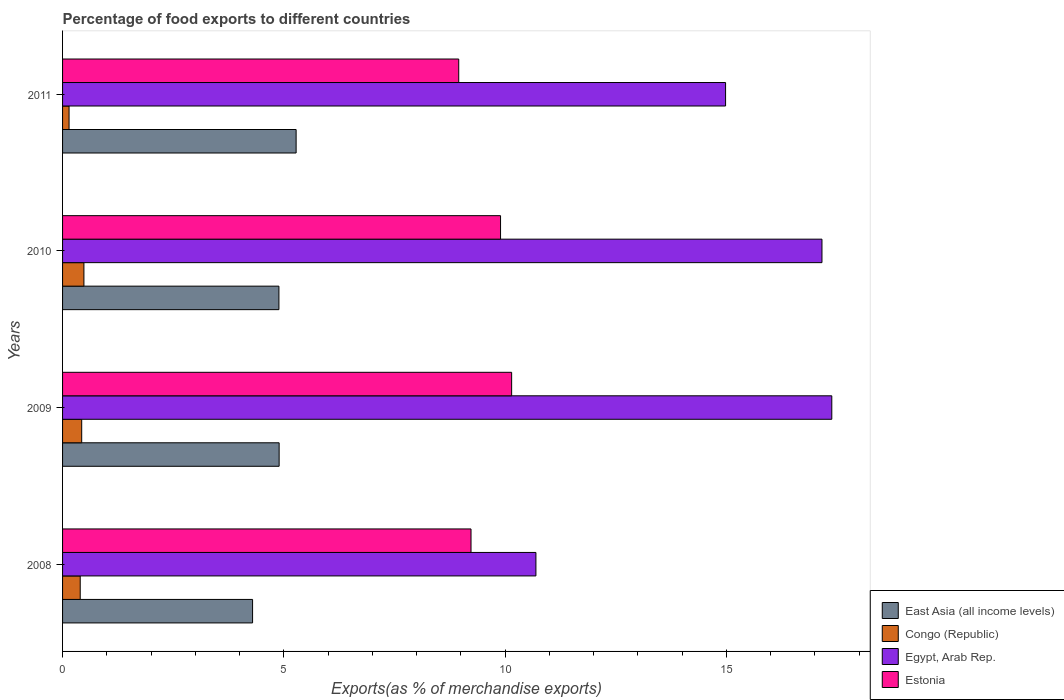How many different coloured bars are there?
Give a very brief answer. 4. How many groups of bars are there?
Your response must be concise. 4. How many bars are there on the 1st tick from the bottom?
Offer a terse response. 4. What is the label of the 3rd group of bars from the top?
Ensure brevity in your answer.  2009. What is the percentage of exports to different countries in Estonia in 2011?
Provide a succinct answer. 8.95. Across all years, what is the maximum percentage of exports to different countries in Congo (Republic)?
Provide a succinct answer. 0.48. Across all years, what is the minimum percentage of exports to different countries in East Asia (all income levels)?
Offer a terse response. 4.29. What is the total percentage of exports to different countries in Estonia in the graph?
Keep it short and to the point. 38.23. What is the difference between the percentage of exports to different countries in East Asia (all income levels) in 2010 and that in 2011?
Offer a terse response. -0.39. What is the difference between the percentage of exports to different countries in Egypt, Arab Rep. in 2009 and the percentage of exports to different countries in East Asia (all income levels) in 2008?
Give a very brief answer. 13.09. What is the average percentage of exports to different countries in Estonia per year?
Your answer should be very brief. 9.56. In the year 2009, what is the difference between the percentage of exports to different countries in Egypt, Arab Rep. and percentage of exports to different countries in Estonia?
Provide a short and direct response. 7.24. What is the ratio of the percentage of exports to different countries in Egypt, Arab Rep. in 2009 to that in 2010?
Give a very brief answer. 1.01. Is the difference between the percentage of exports to different countries in Egypt, Arab Rep. in 2009 and 2010 greater than the difference between the percentage of exports to different countries in Estonia in 2009 and 2010?
Provide a short and direct response. No. What is the difference between the highest and the second highest percentage of exports to different countries in Egypt, Arab Rep.?
Provide a short and direct response. 0.22. What is the difference between the highest and the lowest percentage of exports to different countries in East Asia (all income levels)?
Ensure brevity in your answer.  0.98. Is the sum of the percentage of exports to different countries in Egypt, Arab Rep. in 2009 and 2010 greater than the maximum percentage of exports to different countries in East Asia (all income levels) across all years?
Offer a very short reply. Yes. What does the 1st bar from the top in 2009 represents?
Offer a very short reply. Estonia. What does the 1st bar from the bottom in 2009 represents?
Provide a short and direct response. East Asia (all income levels). How many years are there in the graph?
Your response must be concise. 4. What is the difference between two consecutive major ticks on the X-axis?
Provide a short and direct response. 5. Does the graph contain grids?
Give a very brief answer. No. Where does the legend appear in the graph?
Your response must be concise. Bottom right. How many legend labels are there?
Ensure brevity in your answer.  4. What is the title of the graph?
Offer a terse response. Percentage of food exports to different countries. Does "Bulgaria" appear as one of the legend labels in the graph?
Provide a short and direct response. No. What is the label or title of the X-axis?
Offer a terse response. Exports(as % of merchandise exports). What is the label or title of the Y-axis?
Offer a very short reply. Years. What is the Exports(as % of merchandise exports) of East Asia (all income levels) in 2008?
Offer a very short reply. 4.29. What is the Exports(as % of merchandise exports) in Congo (Republic) in 2008?
Ensure brevity in your answer.  0.4. What is the Exports(as % of merchandise exports) in Egypt, Arab Rep. in 2008?
Give a very brief answer. 10.7. What is the Exports(as % of merchandise exports) of Estonia in 2008?
Provide a short and direct response. 9.23. What is the Exports(as % of merchandise exports) in East Asia (all income levels) in 2009?
Offer a terse response. 4.89. What is the Exports(as % of merchandise exports) of Congo (Republic) in 2009?
Make the answer very short. 0.43. What is the Exports(as % of merchandise exports) in Egypt, Arab Rep. in 2009?
Your response must be concise. 17.38. What is the Exports(as % of merchandise exports) of Estonia in 2009?
Ensure brevity in your answer.  10.15. What is the Exports(as % of merchandise exports) of East Asia (all income levels) in 2010?
Give a very brief answer. 4.89. What is the Exports(as % of merchandise exports) of Congo (Republic) in 2010?
Your response must be concise. 0.48. What is the Exports(as % of merchandise exports) of Egypt, Arab Rep. in 2010?
Keep it short and to the point. 17.16. What is the Exports(as % of merchandise exports) in Estonia in 2010?
Your answer should be compact. 9.9. What is the Exports(as % of merchandise exports) in East Asia (all income levels) in 2011?
Keep it short and to the point. 5.28. What is the Exports(as % of merchandise exports) of Congo (Republic) in 2011?
Provide a succinct answer. 0.15. What is the Exports(as % of merchandise exports) in Egypt, Arab Rep. in 2011?
Ensure brevity in your answer.  14.98. What is the Exports(as % of merchandise exports) of Estonia in 2011?
Your response must be concise. 8.95. Across all years, what is the maximum Exports(as % of merchandise exports) in East Asia (all income levels)?
Offer a terse response. 5.28. Across all years, what is the maximum Exports(as % of merchandise exports) of Congo (Republic)?
Offer a terse response. 0.48. Across all years, what is the maximum Exports(as % of merchandise exports) of Egypt, Arab Rep.?
Ensure brevity in your answer.  17.38. Across all years, what is the maximum Exports(as % of merchandise exports) in Estonia?
Give a very brief answer. 10.15. Across all years, what is the minimum Exports(as % of merchandise exports) in East Asia (all income levels)?
Offer a terse response. 4.29. Across all years, what is the minimum Exports(as % of merchandise exports) of Congo (Republic)?
Your answer should be very brief. 0.15. Across all years, what is the minimum Exports(as % of merchandise exports) of Egypt, Arab Rep.?
Provide a succinct answer. 10.7. Across all years, what is the minimum Exports(as % of merchandise exports) in Estonia?
Offer a terse response. 8.95. What is the total Exports(as % of merchandise exports) of East Asia (all income levels) in the graph?
Your answer should be very brief. 19.36. What is the total Exports(as % of merchandise exports) in Congo (Republic) in the graph?
Give a very brief answer. 1.46. What is the total Exports(as % of merchandise exports) in Egypt, Arab Rep. in the graph?
Offer a terse response. 60.23. What is the total Exports(as % of merchandise exports) of Estonia in the graph?
Your response must be concise. 38.23. What is the difference between the Exports(as % of merchandise exports) of East Asia (all income levels) in 2008 and that in 2009?
Your answer should be very brief. -0.6. What is the difference between the Exports(as % of merchandise exports) in Congo (Republic) in 2008 and that in 2009?
Provide a short and direct response. -0.03. What is the difference between the Exports(as % of merchandise exports) in Egypt, Arab Rep. in 2008 and that in 2009?
Keep it short and to the point. -6.69. What is the difference between the Exports(as % of merchandise exports) of Estonia in 2008 and that in 2009?
Your answer should be compact. -0.92. What is the difference between the Exports(as % of merchandise exports) in East Asia (all income levels) in 2008 and that in 2010?
Offer a terse response. -0.6. What is the difference between the Exports(as % of merchandise exports) in Congo (Republic) in 2008 and that in 2010?
Provide a short and direct response. -0.08. What is the difference between the Exports(as % of merchandise exports) in Egypt, Arab Rep. in 2008 and that in 2010?
Ensure brevity in your answer.  -6.46. What is the difference between the Exports(as % of merchandise exports) in Estonia in 2008 and that in 2010?
Provide a succinct answer. -0.67. What is the difference between the Exports(as % of merchandise exports) in East Asia (all income levels) in 2008 and that in 2011?
Offer a terse response. -0.98. What is the difference between the Exports(as % of merchandise exports) of Congo (Republic) in 2008 and that in 2011?
Make the answer very short. 0.25. What is the difference between the Exports(as % of merchandise exports) in Egypt, Arab Rep. in 2008 and that in 2011?
Give a very brief answer. -4.29. What is the difference between the Exports(as % of merchandise exports) of Estonia in 2008 and that in 2011?
Keep it short and to the point. 0.28. What is the difference between the Exports(as % of merchandise exports) of East Asia (all income levels) in 2009 and that in 2010?
Your response must be concise. 0. What is the difference between the Exports(as % of merchandise exports) of Congo (Republic) in 2009 and that in 2010?
Your response must be concise. -0.05. What is the difference between the Exports(as % of merchandise exports) of Egypt, Arab Rep. in 2009 and that in 2010?
Make the answer very short. 0.22. What is the difference between the Exports(as % of merchandise exports) of Estonia in 2009 and that in 2010?
Your answer should be very brief. 0.25. What is the difference between the Exports(as % of merchandise exports) of East Asia (all income levels) in 2009 and that in 2011?
Provide a short and direct response. -0.38. What is the difference between the Exports(as % of merchandise exports) of Congo (Republic) in 2009 and that in 2011?
Your answer should be very brief. 0.29. What is the difference between the Exports(as % of merchandise exports) of Egypt, Arab Rep. in 2009 and that in 2011?
Ensure brevity in your answer.  2.4. What is the difference between the Exports(as % of merchandise exports) of Estonia in 2009 and that in 2011?
Your answer should be compact. 1.2. What is the difference between the Exports(as % of merchandise exports) in East Asia (all income levels) in 2010 and that in 2011?
Your answer should be compact. -0.39. What is the difference between the Exports(as % of merchandise exports) in Congo (Republic) in 2010 and that in 2011?
Give a very brief answer. 0.34. What is the difference between the Exports(as % of merchandise exports) in Egypt, Arab Rep. in 2010 and that in 2011?
Your response must be concise. 2.18. What is the difference between the Exports(as % of merchandise exports) of Estonia in 2010 and that in 2011?
Your answer should be very brief. 0.95. What is the difference between the Exports(as % of merchandise exports) of East Asia (all income levels) in 2008 and the Exports(as % of merchandise exports) of Congo (Republic) in 2009?
Offer a terse response. 3.86. What is the difference between the Exports(as % of merchandise exports) in East Asia (all income levels) in 2008 and the Exports(as % of merchandise exports) in Egypt, Arab Rep. in 2009?
Keep it short and to the point. -13.09. What is the difference between the Exports(as % of merchandise exports) in East Asia (all income levels) in 2008 and the Exports(as % of merchandise exports) in Estonia in 2009?
Ensure brevity in your answer.  -5.86. What is the difference between the Exports(as % of merchandise exports) in Congo (Republic) in 2008 and the Exports(as % of merchandise exports) in Egypt, Arab Rep. in 2009?
Provide a short and direct response. -16.99. What is the difference between the Exports(as % of merchandise exports) of Congo (Republic) in 2008 and the Exports(as % of merchandise exports) of Estonia in 2009?
Keep it short and to the point. -9.75. What is the difference between the Exports(as % of merchandise exports) in Egypt, Arab Rep. in 2008 and the Exports(as % of merchandise exports) in Estonia in 2009?
Your answer should be very brief. 0.55. What is the difference between the Exports(as % of merchandise exports) in East Asia (all income levels) in 2008 and the Exports(as % of merchandise exports) in Congo (Republic) in 2010?
Give a very brief answer. 3.81. What is the difference between the Exports(as % of merchandise exports) of East Asia (all income levels) in 2008 and the Exports(as % of merchandise exports) of Egypt, Arab Rep. in 2010?
Keep it short and to the point. -12.87. What is the difference between the Exports(as % of merchandise exports) of East Asia (all income levels) in 2008 and the Exports(as % of merchandise exports) of Estonia in 2010?
Your answer should be very brief. -5.6. What is the difference between the Exports(as % of merchandise exports) in Congo (Republic) in 2008 and the Exports(as % of merchandise exports) in Egypt, Arab Rep. in 2010?
Offer a very short reply. -16.76. What is the difference between the Exports(as % of merchandise exports) of Congo (Republic) in 2008 and the Exports(as % of merchandise exports) of Estonia in 2010?
Your response must be concise. -9.5. What is the difference between the Exports(as % of merchandise exports) in Egypt, Arab Rep. in 2008 and the Exports(as % of merchandise exports) in Estonia in 2010?
Your answer should be compact. 0.8. What is the difference between the Exports(as % of merchandise exports) of East Asia (all income levels) in 2008 and the Exports(as % of merchandise exports) of Congo (Republic) in 2011?
Your response must be concise. 4.15. What is the difference between the Exports(as % of merchandise exports) of East Asia (all income levels) in 2008 and the Exports(as % of merchandise exports) of Egypt, Arab Rep. in 2011?
Make the answer very short. -10.69. What is the difference between the Exports(as % of merchandise exports) of East Asia (all income levels) in 2008 and the Exports(as % of merchandise exports) of Estonia in 2011?
Ensure brevity in your answer.  -4.66. What is the difference between the Exports(as % of merchandise exports) of Congo (Republic) in 2008 and the Exports(as % of merchandise exports) of Egypt, Arab Rep. in 2011?
Your response must be concise. -14.59. What is the difference between the Exports(as % of merchandise exports) in Congo (Republic) in 2008 and the Exports(as % of merchandise exports) in Estonia in 2011?
Your answer should be very brief. -8.55. What is the difference between the Exports(as % of merchandise exports) in Egypt, Arab Rep. in 2008 and the Exports(as % of merchandise exports) in Estonia in 2011?
Your answer should be compact. 1.74. What is the difference between the Exports(as % of merchandise exports) of East Asia (all income levels) in 2009 and the Exports(as % of merchandise exports) of Congo (Republic) in 2010?
Provide a succinct answer. 4.41. What is the difference between the Exports(as % of merchandise exports) in East Asia (all income levels) in 2009 and the Exports(as % of merchandise exports) in Egypt, Arab Rep. in 2010?
Your answer should be compact. -12.27. What is the difference between the Exports(as % of merchandise exports) of East Asia (all income levels) in 2009 and the Exports(as % of merchandise exports) of Estonia in 2010?
Give a very brief answer. -5. What is the difference between the Exports(as % of merchandise exports) of Congo (Republic) in 2009 and the Exports(as % of merchandise exports) of Egypt, Arab Rep. in 2010?
Provide a succinct answer. -16.73. What is the difference between the Exports(as % of merchandise exports) of Congo (Republic) in 2009 and the Exports(as % of merchandise exports) of Estonia in 2010?
Ensure brevity in your answer.  -9.47. What is the difference between the Exports(as % of merchandise exports) in Egypt, Arab Rep. in 2009 and the Exports(as % of merchandise exports) in Estonia in 2010?
Offer a terse response. 7.49. What is the difference between the Exports(as % of merchandise exports) in East Asia (all income levels) in 2009 and the Exports(as % of merchandise exports) in Congo (Republic) in 2011?
Keep it short and to the point. 4.75. What is the difference between the Exports(as % of merchandise exports) in East Asia (all income levels) in 2009 and the Exports(as % of merchandise exports) in Egypt, Arab Rep. in 2011?
Your answer should be very brief. -10.09. What is the difference between the Exports(as % of merchandise exports) in East Asia (all income levels) in 2009 and the Exports(as % of merchandise exports) in Estonia in 2011?
Ensure brevity in your answer.  -4.06. What is the difference between the Exports(as % of merchandise exports) in Congo (Republic) in 2009 and the Exports(as % of merchandise exports) in Egypt, Arab Rep. in 2011?
Offer a terse response. -14.55. What is the difference between the Exports(as % of merchandise exports) of Congo (Republic) in 2009 and the Exports(as % of merchandise exports) of Estonia in 2011?
Keep it short and to the point. -8.52. What is the difference between the Exports(as % of merchandise exports) of Egypt, Arab Rep. in 2009 and the Exports(as % of merchandise exports) of Estonia in 2011?
Offer a terse response. 8.43. What is the difference between the Exports(as % of merchandise exports) of East Asia (all income levels) in 2010 and the Exports(as % of merchandise exports) of Congo (Republic) in 2011?
Give a very brief answer. 4.74. What is the difference between the Exports(as % of merchandise exports) of East Asia (all income levels) in 2010 and the Exports(as % of merchandise exports) of Egypt, Arab Rep. in 2011?
Make the answer very short. -10.09. What is the difference between the Exports(as % of merchandise exports) of East Asia (all income levels) in 2010 and the Exports(as % of merchandise exports) of Estonia in 2011?
Your answer should be compact. -4.06. What is the difference between the Exports(as % of merchandise exports) of Congo (Republic) in 2010 and the Exports(as % of merchandise exports) of Egypt, Arab Rep. in 2011?
Provide a short and direct response. -14.5. What is the difference between the Exports(as % of merchandise exports) in Congo (Republic) in 2010 and the Exports(as % of merchandise exports) in Estonia in 2011?
Provide a short and direct response. -8.47. What is the difference between the Exports(as % of merchandise exports) in Egypt, Arab Rep. in 2010 and the Exports(as % of merchandise exports) in Estonia in 2011?
Ensure brevity in your answer.  8.21. What is the average Exports(as % of merchandise exports) in East Asia (all income levels) per year?
Keep it short and to the point. 4.84. What is the average Exports(as % of merchandise exports) in Congo (Republic) per year?
Offer a terse response. 0.37. What is the average Exports(as % of merchandise exports) in Egypt, Arab Rep. per year?
Ensure brevity in your answer.  15.06. What is the average Exports(as % of merchandise exports) of Estonia per year?
Keep it short and to the point. 9.56. In the year 2008, what is the difference between the Exports(as % of merchandise exports) of East Asia (all income levels) and Exports(as % of merchandise exports) of Congo (Republic)?
Provide a succinct answer. 3.9. In the year 2008, what is the difference between the Exports(as % of merchandise exports) of East Asia (all income levels) and Exports(as % of merchandise exports) of Egypt, Arab Rep.?
Your answer should be compact. -6.4. In the year 2008, what is the difference between the Exports(as % of merchandise exports) of East Asia (all income levels) and Exports(as % of merchandise exports) of Estonia?
Your answer should be compact. -4.94. In the year 2008, what is the difference between the Exports(as % of merchandise exports) of Congo (Republic) and Exports(as % of merchandise exports) of Egypt, Arab Rep.?
Your answer should be compact. -10.3. In the year 2008, what is the difference between the Exports(as % of merchandise exports) of Congo (Republic) and Exports(as % of merchandise exports) of Estonia?
Offer a terse response. -8.83. In the year 2008, what is the difference between the Exports(as % of merchandise exports) of Egypt, Arab Rep. and Exports(as % of merchandise exports) of Estonia?
Your response must be concise. 1.47. In the year 2009, what is the difference between the Exports(as % of merchandise exports) of East Asia (all income levels) and Exports(as % of merchandise exports) of Congo (Republic)?
Your response must be concise. 4.46. In the year 2009, what is the difference between the Exports(as % of merchandise exports) in East Asia (all income levels) and Exports(as % of merchandise exports) in Egypt, Arab Rep.?
Provide a short and direct response. -12.49. In the year 2009, what is the difference between the Exports(as % of merchandise exports) in East Asia (all income levels) and Exports(as % of merchandise exports) in Estonia?
Keep it short and to the point. -5.25. In the year 2009, what is the difference between the Exports(as % of merchandise exports) of Congo (Republic) and Exports(as % of merchandise exports) of Egypt, Arab Rep.?
Offer a very short reply. -16.95. In the year 2009, what is the difference between the Exports(as % of merchandise exports) in Congo (Republic) and Exports(as % of merchandise exports) in Estonia?
Offer a very short reply. -9.72. In the year 2009, what is the difference between the Exports(as % of merchandise exports) in Egypt, Arab Rep. and Exports(as % of merchandise exports) in Estonia?
Offer a very short reply. 7.24. In the year 2010, what is the difference between the Exports(as % of merchandise exports) in East Asia (all income levels) and Exports(as % of merchandise exports) in Congo (Republic)?
Your response must be concise. 4.41. In the year 2010, what is the difference between the Exports(as % of merchandise exports) in East Asia (all income levels) and Exports(as % of merchandise exports) in Egypt, Arab Rep.?
Ensure brevity in your answer.  -12.27. In the year 2010, what is the difference between the Exports(as % of merchandise exports) in East Asia (all income levels) and Exports(as % of merchandise exports) in Estonia?
Your answer should be compact. -5.01. In the year 2010, what is the difference between the Exports(as % of merchandise exports) in Congo (Republic) and Exports(as % of merchandise exports) in Egypt, Arab Rep.?
Your answer should be very brief. -16.68. In the year 2010, what is the difference between the Exports(as % of merchandise exports) of Congo (Republic) and Exports(as % of merchandise exports) of Estonia?
Keep it short and to the point. -9.42. In the year 2010, what is the difference between the Exports(as % of merchandise exports) of Egypt, Arab Rep. and Exports(as % of merchandise exports) of Estonia?
Keep it short and to the point. 7.26. In the year 2011, what is the difference between the Exports(as % of merchandise exports) in East Asia (all income levels) and Exports(as % of merchandise exports) in Congo (Republic)?
Keep it short and to the point. 5.13. In the year 2011, what is the difference between the Exports(as % of merchandise exports) in East Asia (all income levels) and Exports(as % of merchandise exports) in Egypt, Arab Rep.?
Your response must be concise. -9.71. In the year 2011, what is the difference between the Exports(as % of merchandise exports) in East Asia (all income levels) and Exports(as % of merchandise exports) in Estonia?
Provide a short and direct response. -3.67. In the year 2011, what is the difference between the Exports(as % of merchandise exports) in Congo (Republic) and Exports(as % of merchandise exports) in Egypt, Arab Rep.?
Make the answer very short. -14.84. In the year 2011, what is the difference between the Exports(as % of merchandise exports) of Congo (Republic) and Exports(as % of merchandise exports) of Estonia?
Provide a short and direct response. -8.81. In the year 2011, what is the difference between the Exports(as % of merchandise exports) of Egypt, Arab Rep. and Exports(as % of merchandise exports) of Estonia?
Ensure brevity in your answer.  6.03. What is the ratio of the Exports(as % of merchandise exports) of East Asia (all income levels) in 2008 to that in 2009?
Offer a very short reply. 0.88. What is the ratio of the Exports(as % of merchandise exports) in Congo (Republic) in 2008 to that in 2009?
Give a very brief answer. 0.92. What is the ratio of the Exports(as % of merchandise exports) in Egypt, Arab Rep. in 2008 to that in 2009?
Your answer should be very brief. 0.62. What is the ratio of the Exports(as % of merchandise exports) in Estonia in 2008 to that in 2009?
Offer a very short reply. 0.91. What is the ratio of the Exports(as % of merchandise exports) in East Asia (all income levels) in 2008 to that in 2010?
Provide a succinct answer. 0.88. What is the ratio of the Exports(as % of merchandise exports) of Congo (Republic) in 2008 to that in 2010?
Offer a terse response. 0.83. What is the ratio of the Exports(as % of merchandise exports) of Egypt, Arab Rep. in 2008 to that in 2010?
Give a very brief answer. 0.62. What is the ratio of the Exports(as % of merchandise exports) of Estonia in 2008 to that in 2010?
Offer a very short reply. 0.93. What is the ratio of the Exports(as % of merchandise exports) of East Asia (all income levels) in 2008 to that in 2011?
Keep it short and to the point. 0.81. What is the ratio of the Exports(as % of merchandise exports) in Congo (Republic) in 2008 to that in 2011?
Keep it short and to the point. 2.72. What is the ratio of the Exports(as % of merchandise exports) of Egypt, Arab Rep. in 2008 to that in 2011?
Make the answer very short. 0.71. What is the ratio of the Exports(as % of merchandise exports) in Estonia in 2008 to that in 2011?
Your response must be concise. 1.03. What is the ratio of the Exports(as % of merchandise exports) in East Asia (all income levels) in 2009 to that in 2010?
Provide a succinct answer. 1. What is the ratio of the Exports(as % of merchandise exports) of Congo (Republic) in 2009 to that in 2010?
Ensure brevity in your answer.  0.9. What is the ratio of the Exports(as % of merchandise exports) in Egypt, Arab Rep. in 2009 to that in 2010?
Make the answer very short. 1.01. What is the ratio of the Exports(as % of merchandise exports) of Estonia in 2009 to that in 2010?
Make the answer very short. 1.03. What is the ratio of the Exports(as % of merchandise exports) in East Asia (all income levels) in 2009 to that in 2011?
Provide a short and direct response. 0.93. What is the ratio of the Exports(as % of merchandise exports) in Congo (Republic) in 2009 to that in 2011?
Make the answer very short. 2.94. What is the ratio of the Exports(as % of merchandise exports) in Egypt, Arab Rep. in 2009 to that in 2011?
Your answer should be compact. 1.16. What is the ratio of the Exports(as % of merchandise exports) of Estonia in 2009 to that in 2011?
Provide a short and direct response. 1.13. What is the ratio of the Exports(as % of merchandise exports) in East Asia (all income levels) in 2010 to that in 2011?
Give a very brief answer. 0.93. What is the ratio of the Exports(as % of merchandise exports) of Congo (Republic) in 2010 to that in 2011?
Ensure brevity in your answer.  3.29. What is the ratio of the Exports(as % of merchandise exports) of Egypt, Arab Rep. in 2010 to that in 2011?
Provide a succinct answer. 1.15. What is the ratio of the Exports(as % of merchandise exports) of Estonia in 2010 to that in 2011?
Give a very brief answer. 1.11. What is the difference between the highest and the second highest Exports(as % of merchandise exports) in East Asia (all income levels)?
Make the answer very short. 0.38. What is the difference between the highest and the second highest Exports(as % of merchandise exports) in Congo (Republic)?
Give a very brief answer. 0.05. What is the difference between the highest and the second highest Exports(as % of merchandise exports) in Egypt, Arab Rep.?
Offer a terse response. 0.22. What is the difference between the highest and the second highest Exports(as % of merchandise exports) in Estonia?
Your answer should be very brief. 0.25. What is the difference between the highest and the lowest Exports(as % of merchandise exports) of Congo (Republic)?
Provide a succinct answer. 0.34. What is the difference between the highest and the lowest Exports(as % of merchandise exports) of Egypt, Arab Rep.?
Provide a succinct answer. 6.69. What is the difference between the highest and the lowest Exports(as % of merchandise exports) in Estonia?
Your response must be concise. 1.2. 